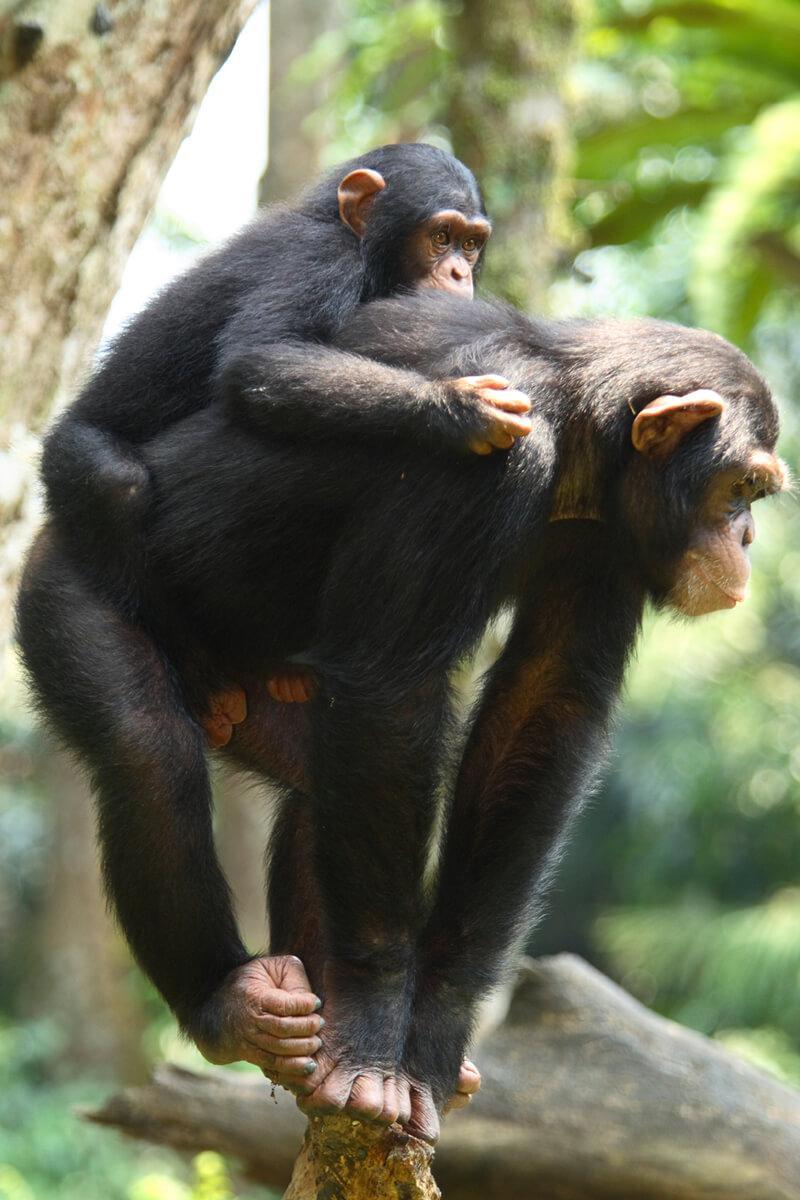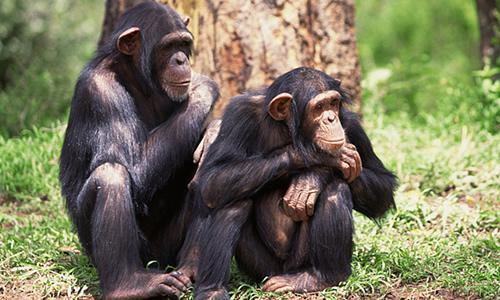The first image is the image on the left, the second image is the image on the right. Analyze the images presented: Is the assertion "There is exactly one animal in the image on the left." valid? Answer yes or no. No. The first image is the image on the left, the second image is the image on the right. For the images shown, is this caption "One of the images shows only one animal." true? Answer yes or no. No. The first image is the image on the left, the second image is the image on the right. Analyze the images presented: Is the assertion "An image shows two very similar looking young chimps side by side." valid? Answer yes or no. Yes. 